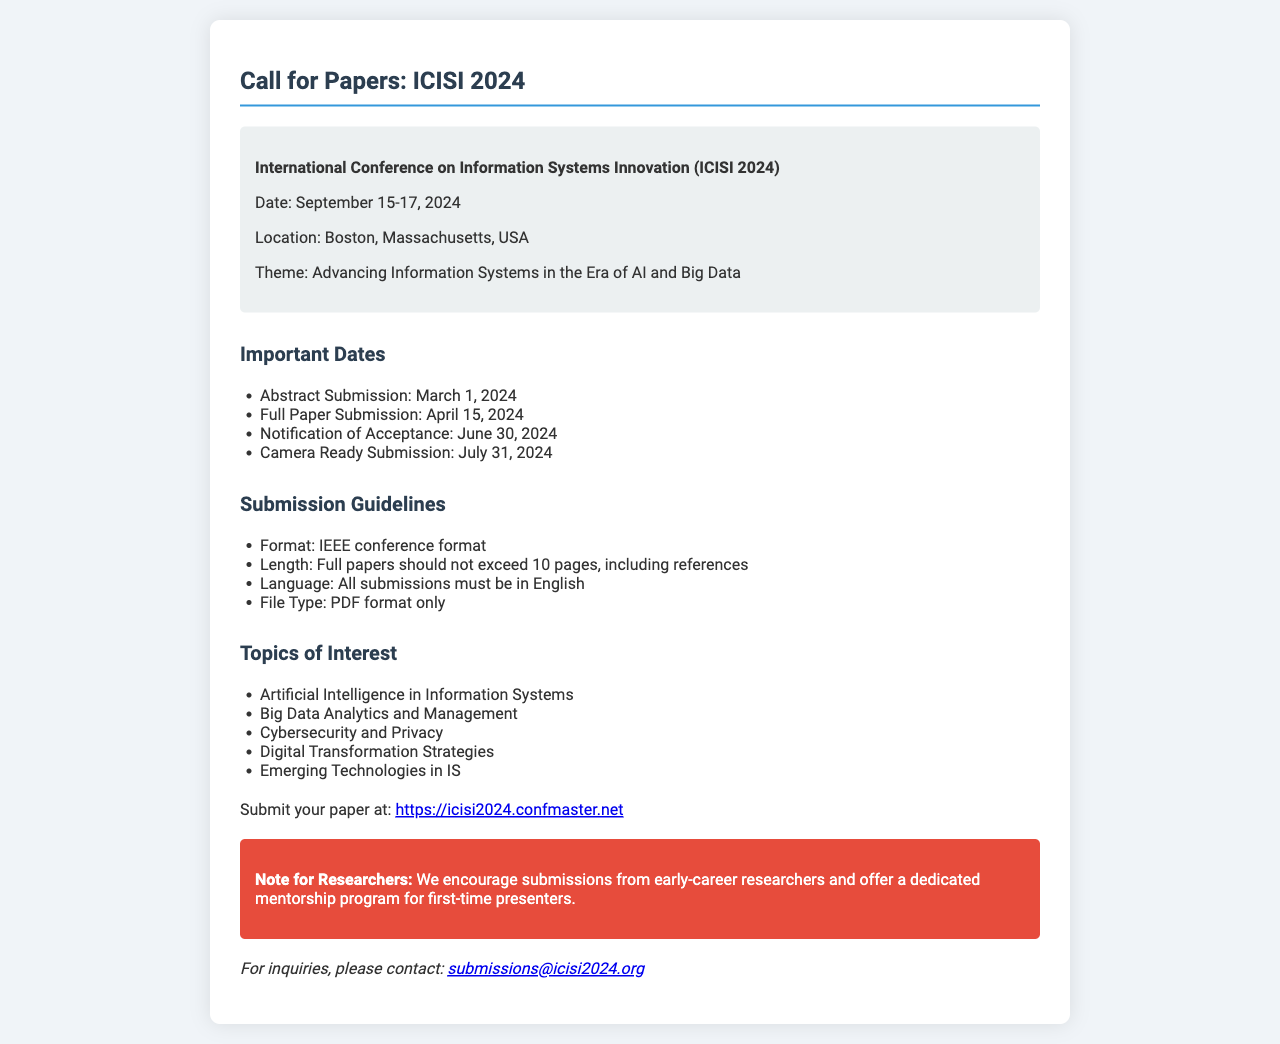What are the dates of the conference? The dates of the conference are mentioned in the conference information section, which states "September 15-17, 2024."
Answer: September 15-17, 2024 What is the theme of the conference? The theme of the conference is provided in the conference info section, which specifies "Advancing Information Systems in the Era of AI and Big Data."
Answer: Advancing Information Systems in the Era of AI and Big Data What is the full paper submission deadline? The full paper submission deadline is outlined under important dates, which states "April 15, 2024."
Answer: April 15, 2024 What format should submissions be in? The submission format is clearly stated in the submission guidelines as "IEEE conference format."
Answer: IEEE conference format Which topic is related to privacy? The topics of interest include a specific item related to privacy, which is "Cybersecurity and Privacy."
Answer: Cybersecurity and Privacy What type of submission is encouraged for early-career researchers? The document mentions a specific program for early-career researchers, which is the "dedicated mentorship program for first-time presenters."
Answer: Dedicated mentorship program for first-time presenters How should the submissions be saved? The submission guidelines specify the file type for submissions as "PDF format only."
Answer: PDF format only When will notifications of acceptance be sent? The notification date is stated in the important dates section, which specifies "June 30, 2024."
Answer: June 30, 2024 What is the URL for paper submission? The document provides the submission URL in the relevant section, which is "https://icisi2024.confmaster.net."
Answer: https://icisi2024.confmaster.net 